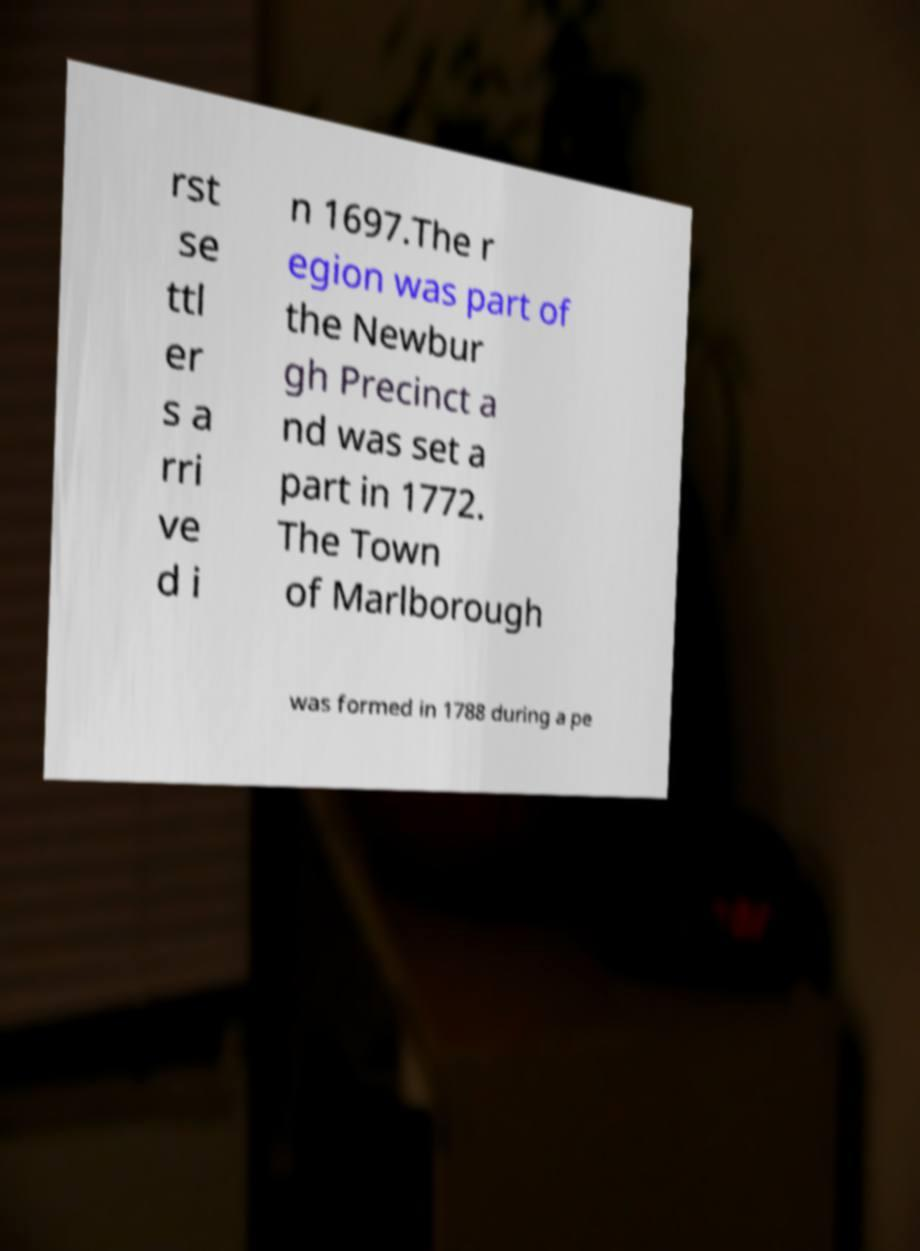Could you assist in decoding the text presented in this image and type it out clearly? rst se ttl er s a rri ve d i n 1697.The r egion was part of the Newbur gh Precinct a nd was set a part in 1772. The Town of Marlborough was formed in 1788 during a pe 